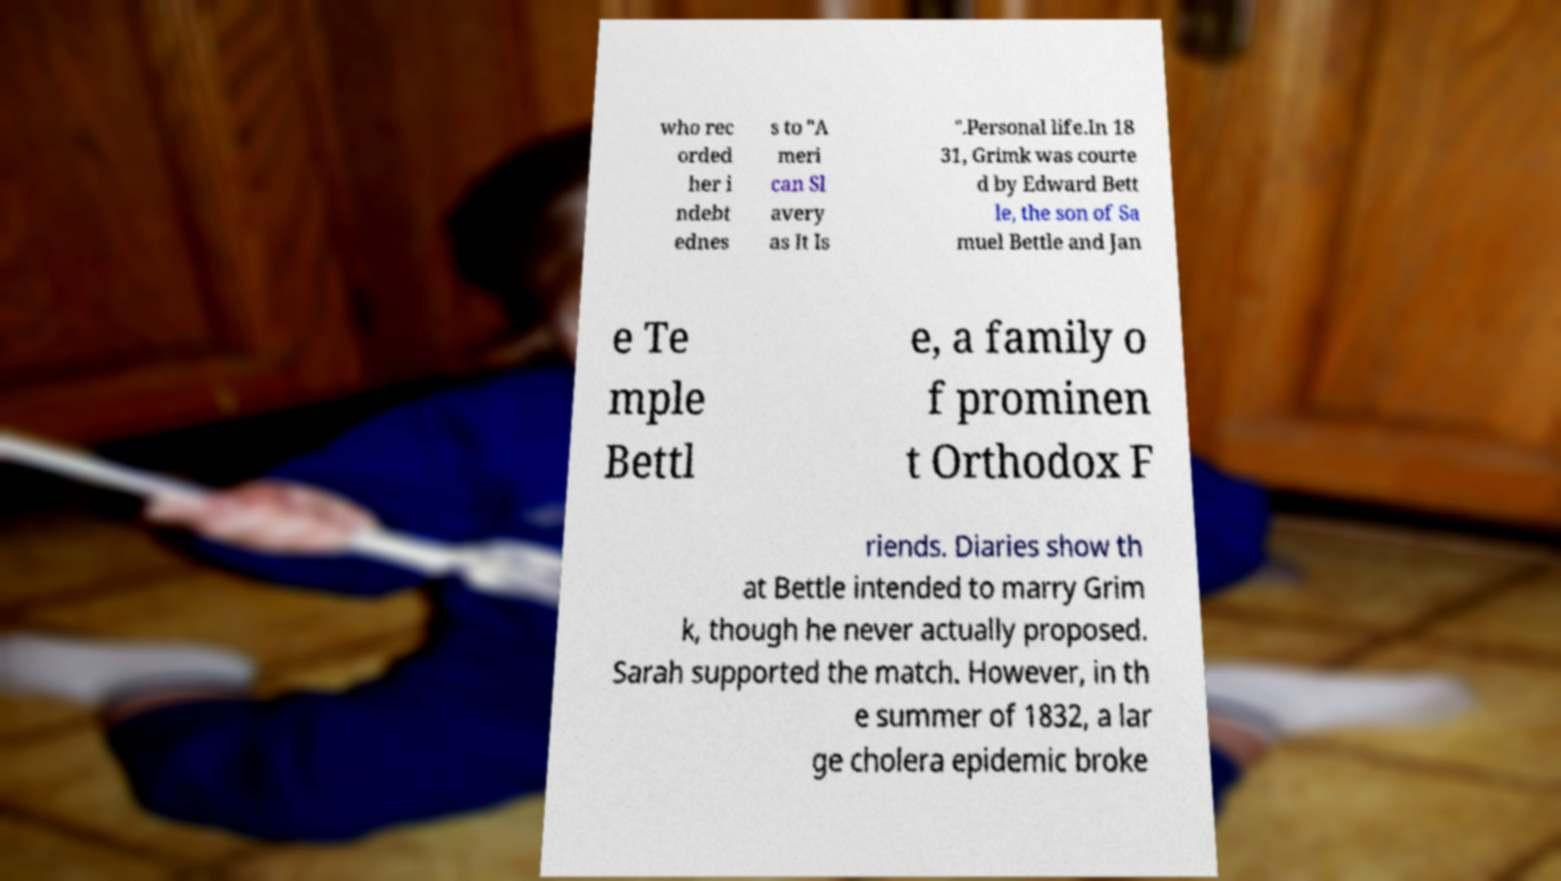There's text embedded in this image that I need extracted. Can you transcribe it verbatim? who rec orded her i ndebt ednes s to "A meri can Sl avery as It Is ".Personal life.In 18 31, Grimk was courte d by Edward Bett le, the son of Sa muel Bettle and Jan e Te mple Bettl e, a family o f prominen t Orthodox F riends. Diaries show th at Bettle intended to marry Grim k, though he never actually proposed. Sarah supported the match. However, in th e summer of 1832, a lar ge cholera epidemic broke 